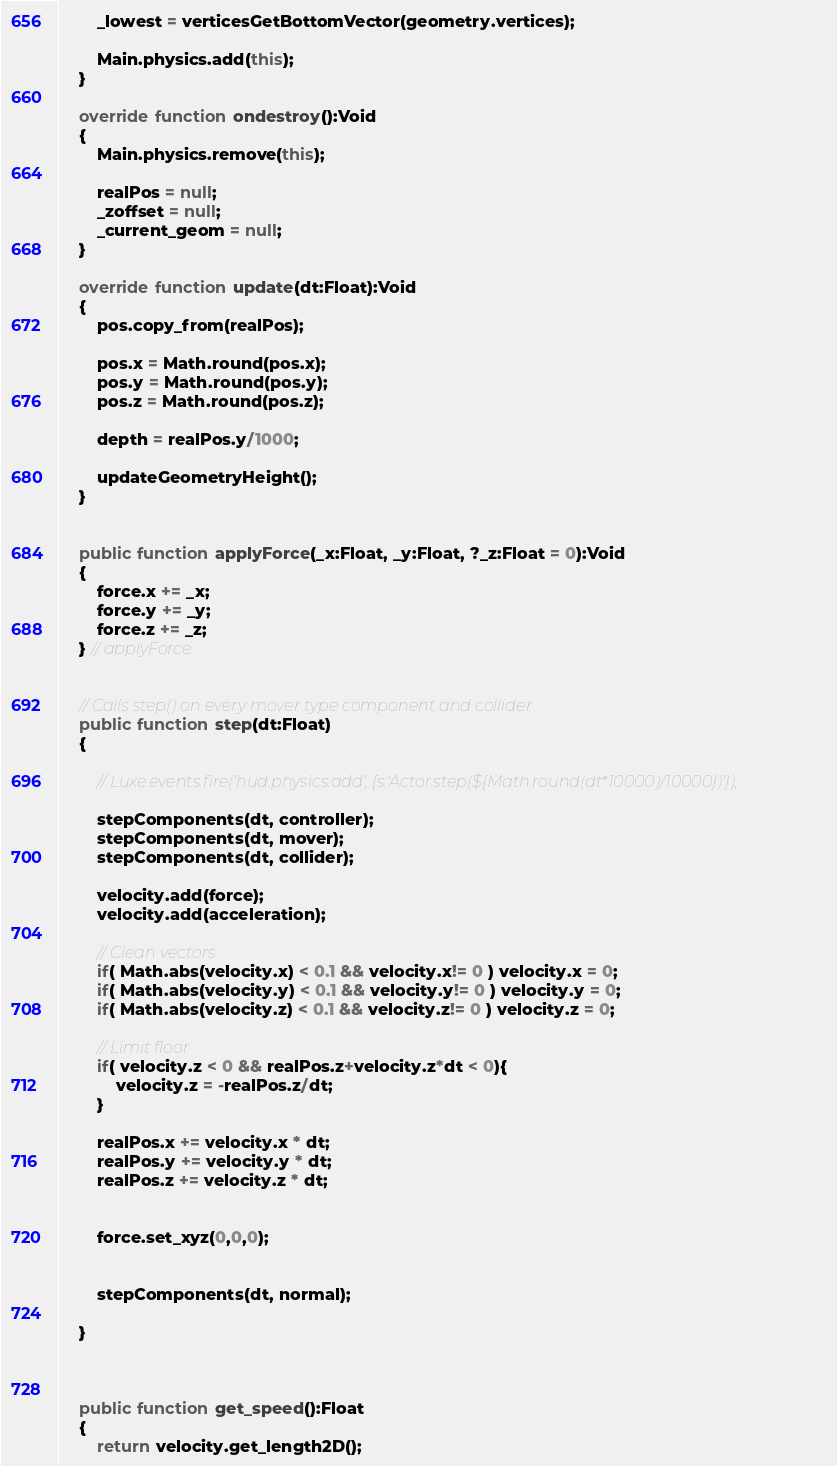<code> <loc_0><loc_0><loc_500><loc_500><_Haxe_>        _lowest = verticesGetBottomVector(geometry.vertices);

        Main.physics.add(this);
    }

    override function ondestroy():Void
    {
        Main.physics.remove(this);

        realPos = null;
        _zoffset = null;
        _current_geom = null;
    }

    override function update(dt:Float):Void
    {
        pos.copy_from(realPos);

        pos.x = Math.round(pos.x);
        pos.y = Math.round(pos.y);
        pos.z = Math.round(pos.z);

        depth = realPos.y/1000;

        updateGeometryHeight();
    }


    public function applyForce(_x:Float, _y:Float, ?_z:Float = 0):Void
    {
        force.x += _x;
        force.y += _y;
        force.z += _z;
    } // applyForce


    // Calls step() on every mover type component and collider
    public function step(dt:Float)
    {

        // Luxe.events.fire('hud.physics.add', {s:'Actor.step(${Math.round(dt*10000)/10000})'});

        stepComponents(dt, controller);
        stepComponents(dt, mover);
        stepComponents(dt, collider);

        velocity.add(force);
        velocity.add(acceleration);

        // Clean vectors
        if( Math.abs(velocity.x) < 0.1 && velocity.x!= 0 ) velocity.x = 0;
        if( Math.abs(velocity.y) < 0.1 && velocity.y!= 0 ) velocity.y = 0;
        if( Math.abs(velocity.z) < 0.1 && velocity.z!= 0 ) velocity.z = 0;

        // Limit floor
        if( velocity.z < 0 && realPos.z+velocity.z*dt < 0){
            velocity.z = -realPos.z/dt;
        }

        realPos.x += velocity.x * dt;
        realPos.y += velocity.y * dt;
        realPos.z += velocity.z * dt;


        force.set_xyz(0,0,0);


        stepComponents(dt, normal);

    }



    public function get_speed():Float
    {
        return velocity.get_length2D();</code> 